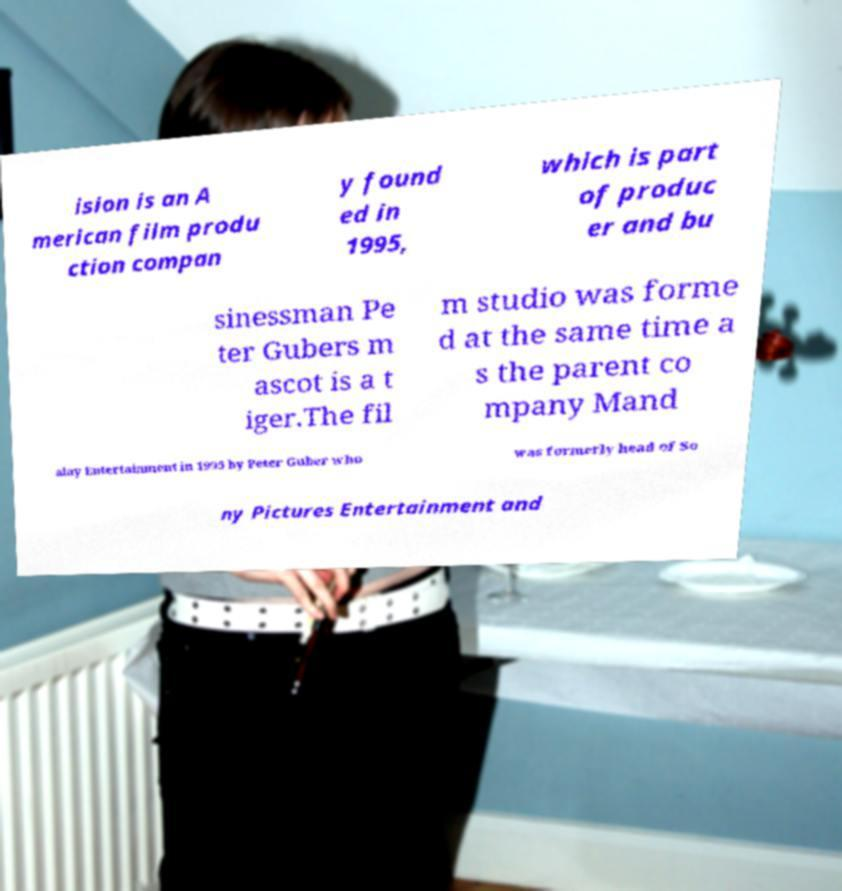Can you read and provide the text displayed in the image?This photo seems to have some interesting text. Can you extract and type it out for me? ision is an A merican film produ ction compan y found ed in 1995, which is part of produc er and bu sinessman Pe ter Gubers m ascot is a t iger.The fil m studio was forme d at the same time a s the parent co mpany Mand alay Entertainment in 1995 by Peter Guber who was formerly head of So ny Pictures Entertainment and 